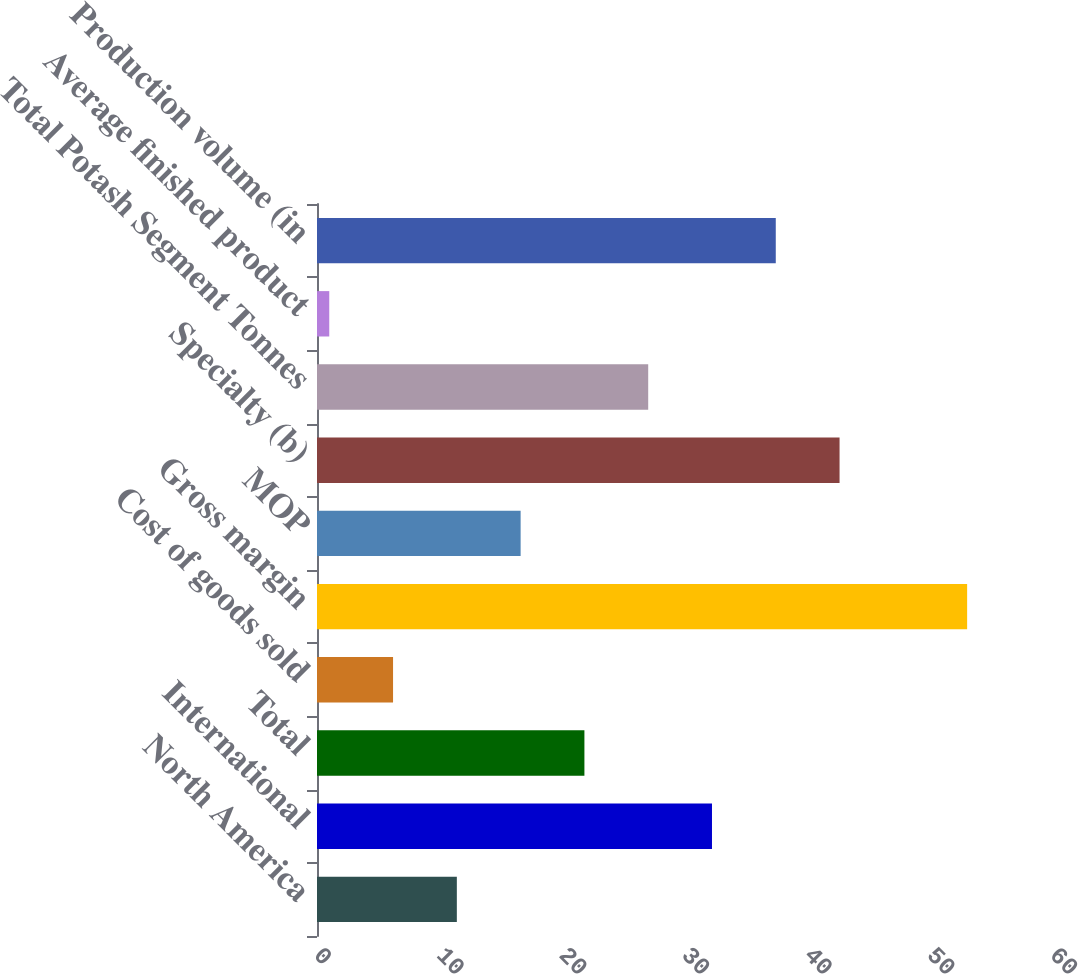Convert chart. <chart><loc_0><loc_0><loc_500><loc_500><bar_chart><fcel>North America<fcel>International<fcel>Total<fcel>Cost of goods sold<fcel>Gross margin<fcel>MOP<fcel>Specialty (b)<fcel>Total Potash Segment Tonnes<fcel>Average finished product<fcel>Production volume (in<nl><fcel>11.4<fcel>32.2<fcel>21.8<fcel>6.2<fcel>53<fcel>16.6<fcel>42.6<fcel>27<fcel>1<fcel>37.4<nl></chart> 